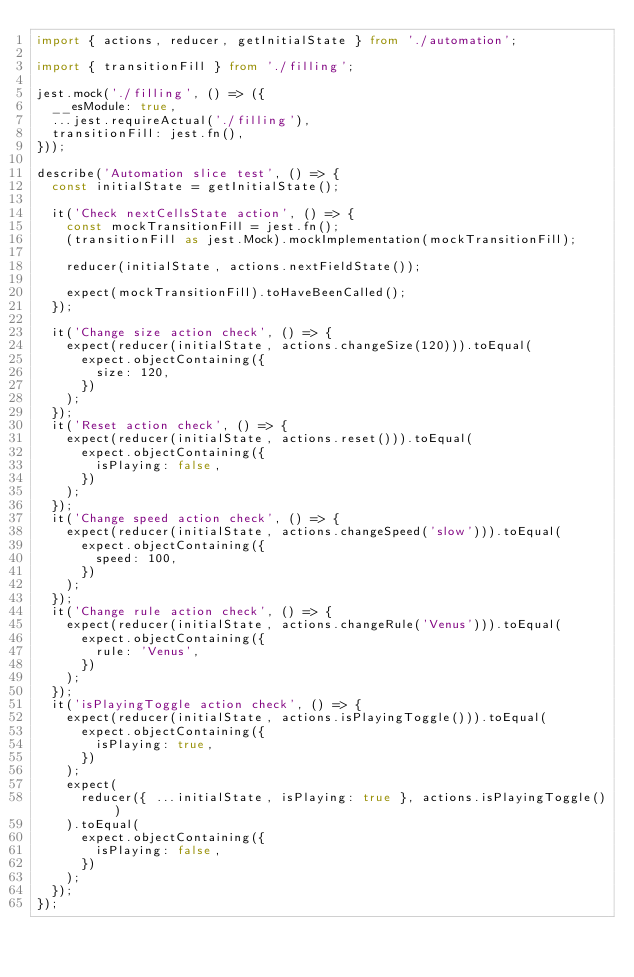<code> <loc_0><loc_0><loc_500><loc_500><_TypeScript_>import { actions, reducer, getInitialState } from './automation';

import { transitionFill } from './filling';

jest.mock('./filling', () => ({
  __esModule: true,
  ...jest.requireActual('./filling'),
  transitionFill: jest.fn(),
}));

describe('Automation slice test', () => {
  const initialState = getInitialState();

  it('Check nextCellsState action', () => {
    const mockTransitionFill = jest.fn();
    (transitionFill as jest.Mock).mockImplementation(mockTransitionFill);

    reducer(initialState, actions.nextFieldState());

    expect(mockTransitionFill).toHaveBeenCalled();
  });

  it('Change size action check', () => {
    expect(reducer(initialState, actions.changeSize(120))).toEqual(
      expect.objectContaining({
        size: 120,
      })
    );
  });
  it('Reset action check', () => {
    expect(reducer(initialState, actions.reset())).toEqual(
      expect.objectContaining({
        isPlaying: false,
      })
    );
  });
  it('Change speed action check', () => {
    expect(reducer(initialState, actions.changeSpeed('slow'))).toEqual(
      expect.objectContaining({
        speed: 100,
      })
    );
  });
  it('Change rule action check', () => {
    expect(reducer(initialState, actions.changeRule('Venus'))).toEqual(
      expect.objectContaining({
        rule: 'Venus',
      })
    );
  });
  it('isPlayingToggle action check', () => {
    expect(reducer(initialState, actions.isPlayingToggle())).toEqual(
      expect.objectContaining({
        isPlaying: true,
      })
    );
    expect(
      reducer({ ...initialState, isPlaying: true }, actions.isPlayingToggle())
    ).toEqual(
      expect.objectContaining({
        isPlaying: false,
      })
    );
  });
});
</code> 